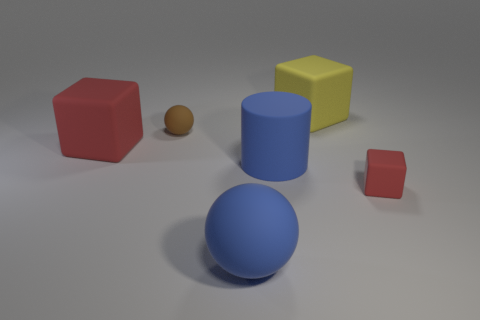What number of other objects are the same shape as the large red rubber object?
Your response must be concise. 2. How many blue things are either small blocks or matte blocks?
Provide a succinct answer. 0. There is a tiny rubber object that is in front of the large red cube; is it the same color as the big sphere?
Make the answer very short. No. What is the shape of the small brown object that is made of the same material as the tiny cube?
Keep it short and to the point. Sphere. What color is the object that is behind the big red matte object and to the right of the small brown matte object?
Make the answer very short. Yellow. There is a cylinder to the left of the small object that is in front of the large red block; what size is it?
Ensure brevity in your answer.  Large. Are there any other small matte balls of the same color as the tiny ball?
Provide a succinct answer. No. Is the number of tiny rubber things that are in front of the brown matte sphere the same as the number of tiny purple matte spheres?
Make the answer very short. No. What number of brown cylinders are there?
Give a very brief answer. 0. What is the shape of the matte object that is in front of the blue matte cylinder and on the left side of the big blue matte cylinder?
Your answer should be compact. Sphere. 